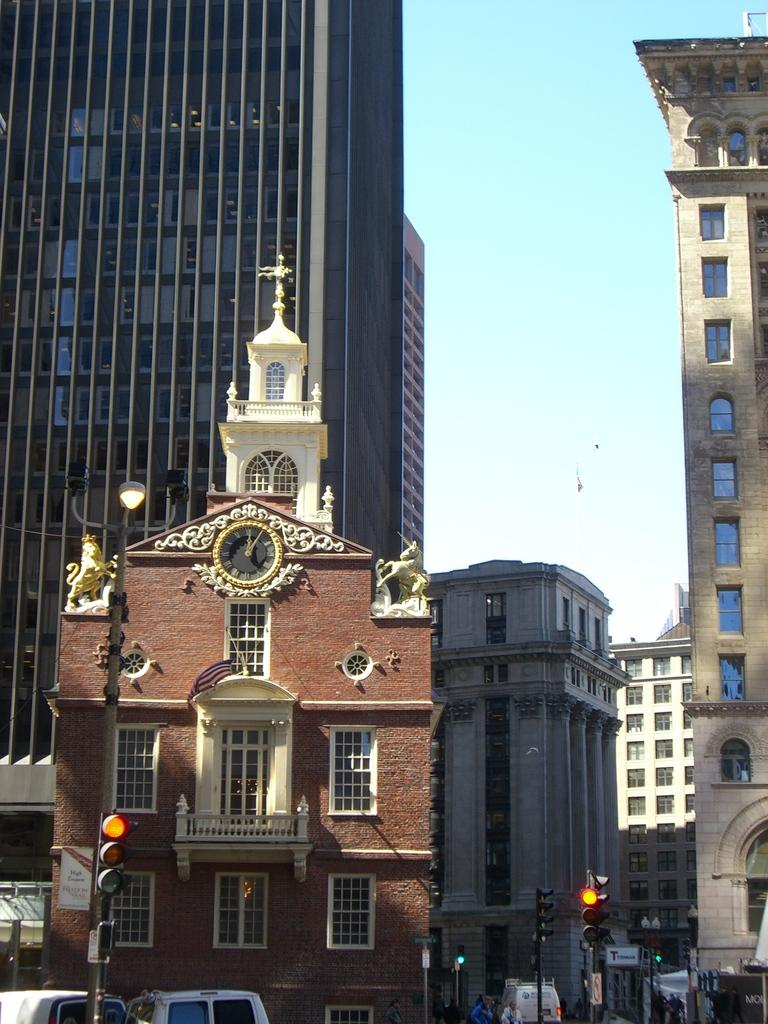What type of structures can be seen in the image? There are buildings in the image. How do the buildings differ from one another? The buildings have different colors and sizes. What can be seen at the bottom of the image? There are signal lights, vehicles, and people at the bottom of the image. What is visible at the top of the image? The sky is visible at the top of the image. Can you tell me what type of lawyer is depicted in the image? There is no lawyer present in the image; it features buildings, signal lights, vehicles, people, and a sky. How many hens can be seen in the image? There are no hens present in the image. 